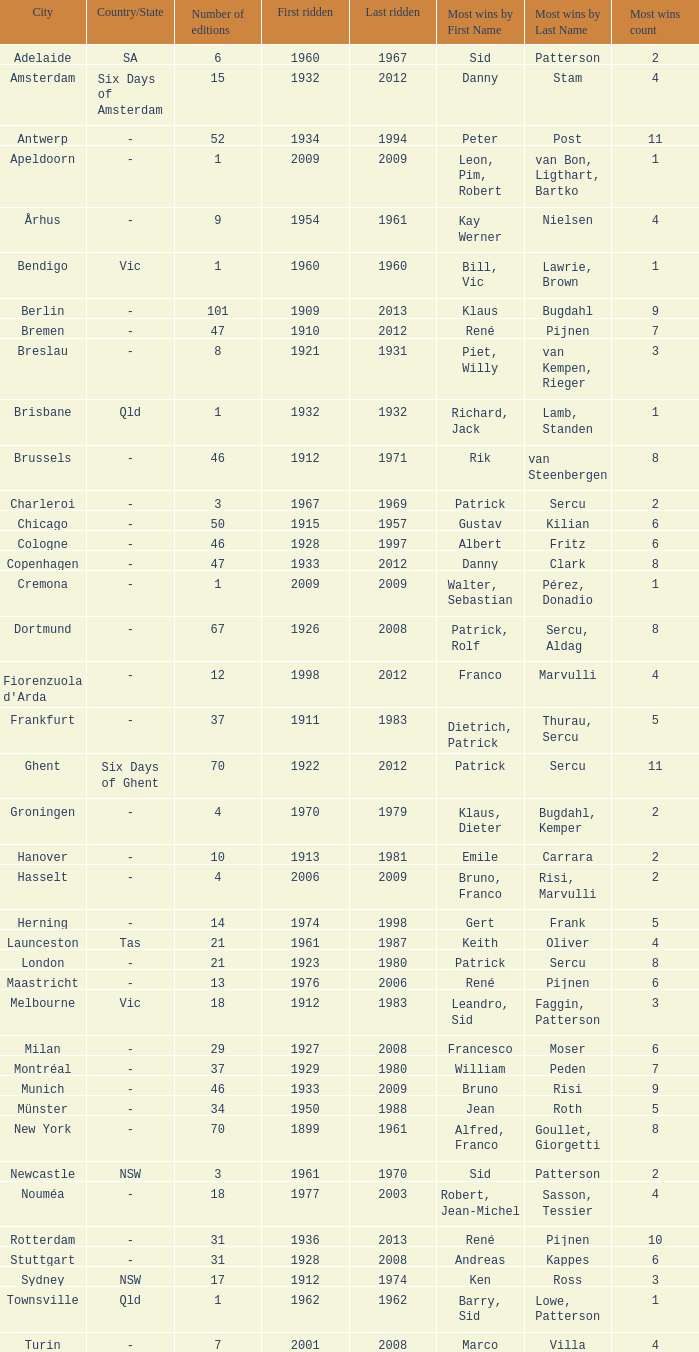How many editions have a most wins value of Franco Marvulli (4)? 1.0. 